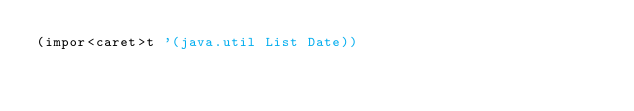Convert code to text. <code><loc_0><loc_0><loc_500><loc_500><_Clojure_>(impor<caret>t '(java.util List Date))</code> 